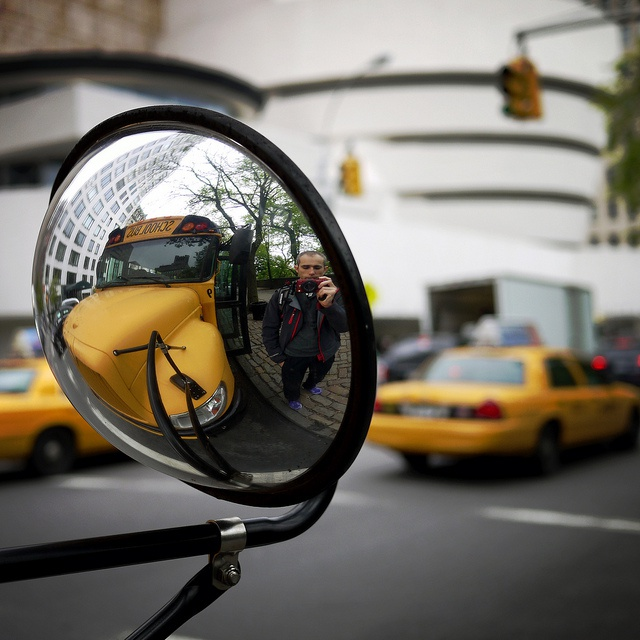Describe the objects in this image and their specific colors. I can see bus in gray, black, olive, and tan tones, car in maroon, black, olive, and darkgray tones, car in maroon, black, brown, and tan tones, people in maroon, black, and gray tones, and car in maroon, gray, black, and darkgray tones in this image. 